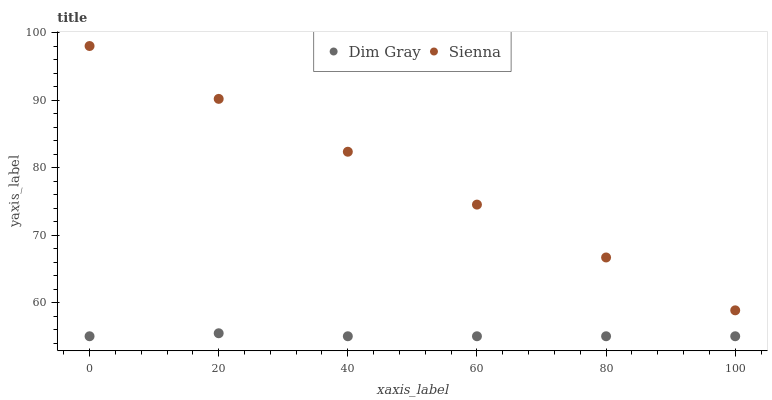Does Dim Gray have the minimum area under the curve?
Answer yes or no. Yes. Does Sienna have the maximum area under the curve?
Answer yes or no. Yes. Does Dim Gray have the maximum area under the curve?
Answer yes or no. No. Is Sienna the smoothest?
Answer yes or no. Yes. Is Dim Gray the roughest?
Answer yes or no. Yes. Is Dim Gray the smoothest?
Answer yes or no. No. Does Dim Gray have the lowest value?
Answer yes or no. Yes. Does Sienna have the highest value?
Answer yes or no. Yes. Does Dim Gray have the highest value?
Answer yes or no. No. Is Dim Gray less than Sienna?
Answer yes or no. Yes. Is Sienna greater than Dim Gray?
Answer yes or no. Yes. Does Dim Gray intersect Sienna?
Answer yes or no. No. 